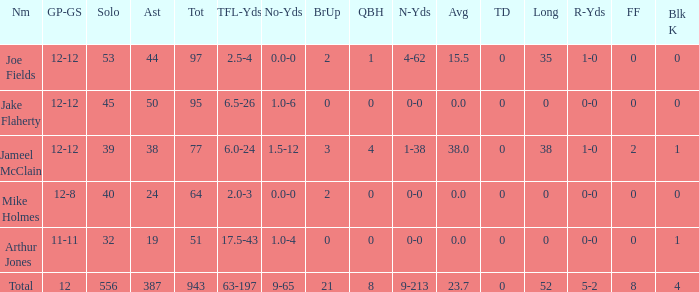What is the total brup for the team? 21.0. 